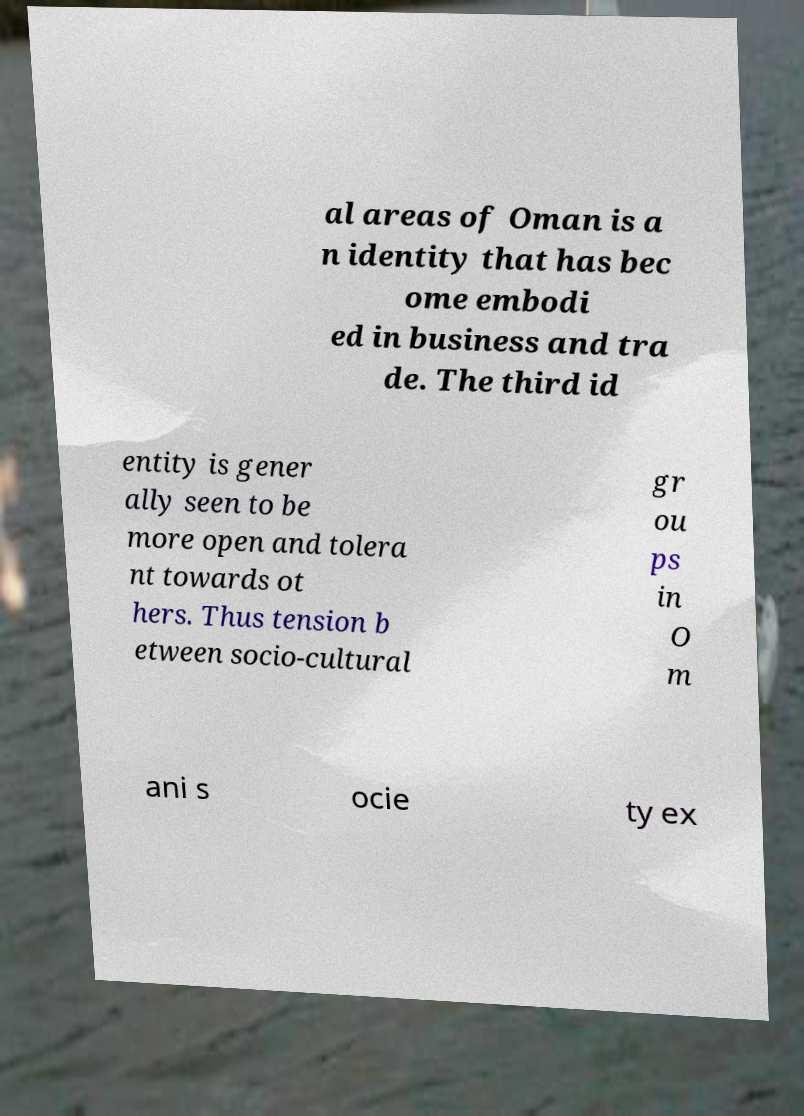Could you extract and type out the text from this image? al areas of Oman is a n identity that has bec ome embodi ed in business and tra de. The third id entity is gener ally seen to be more open and tolera nt towards ot hers. Thus tension b etween socio-cultural gr ou ps in O m ani s ocie ty ex 